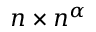Convert formula to latex. <formula><loc_0><loc_0><loc_500><loc_500>n \times n ^ { \alpha }</formula> 